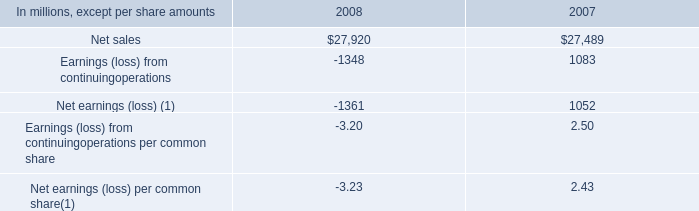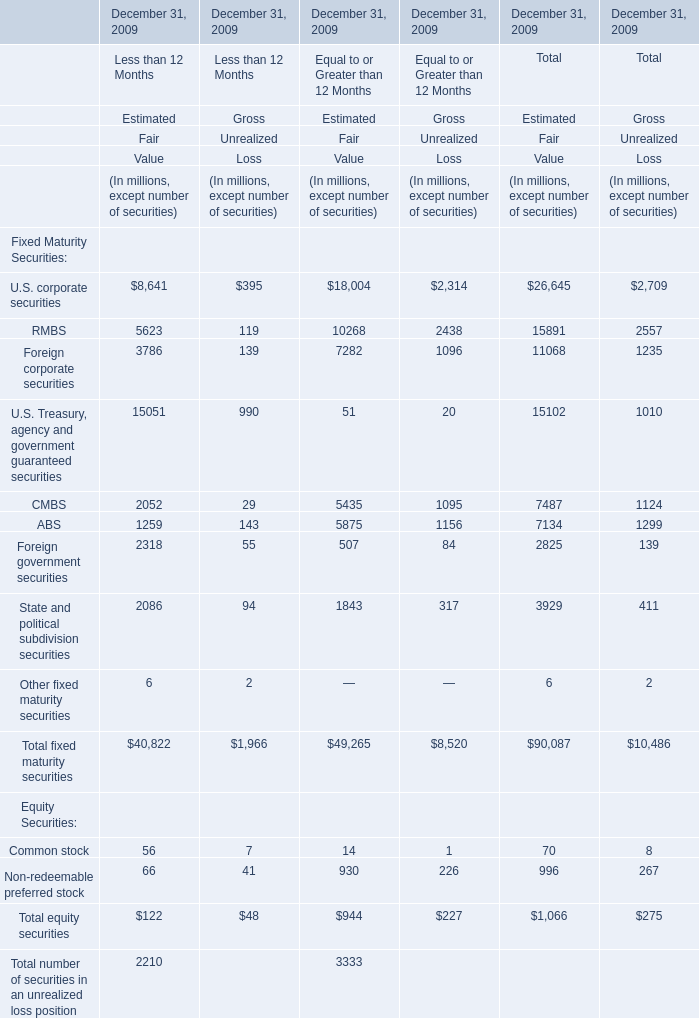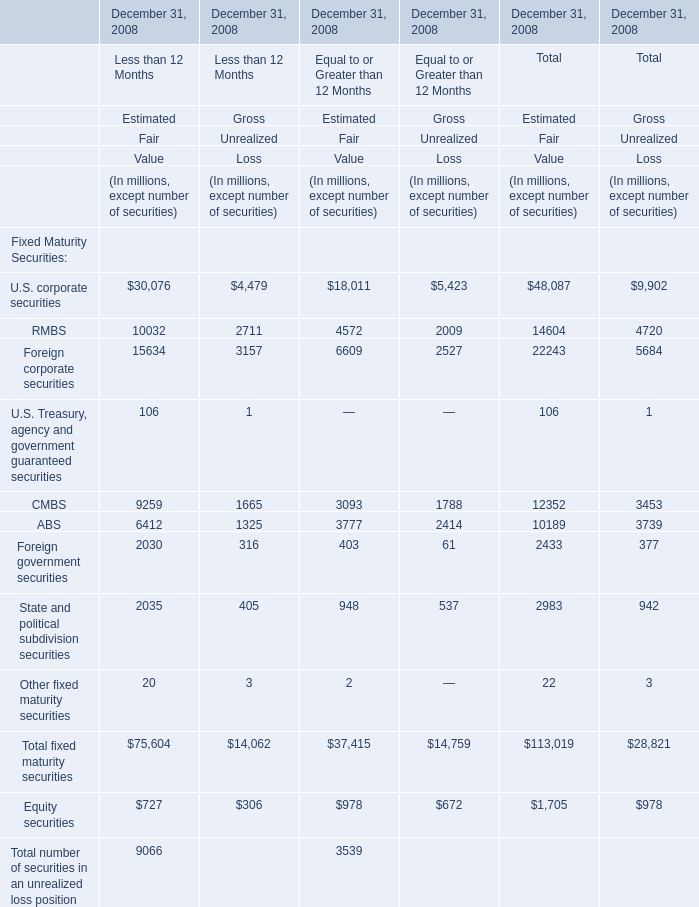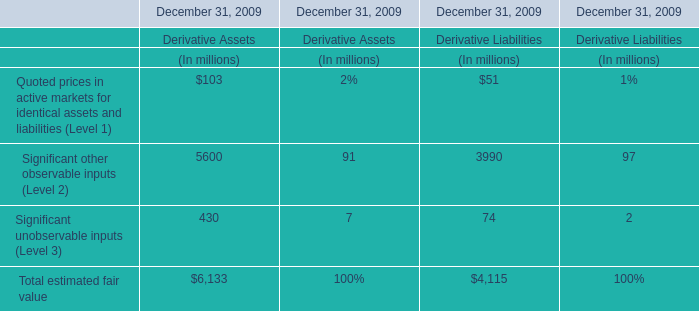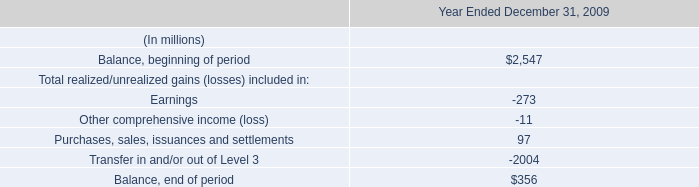What's the 52 % of Estimated Fair Value of Total equity securities for Less than 12 Months as of December 31, 2009? (in million) 
Computations: (0.52 * 122)
Answer: 63.44. 